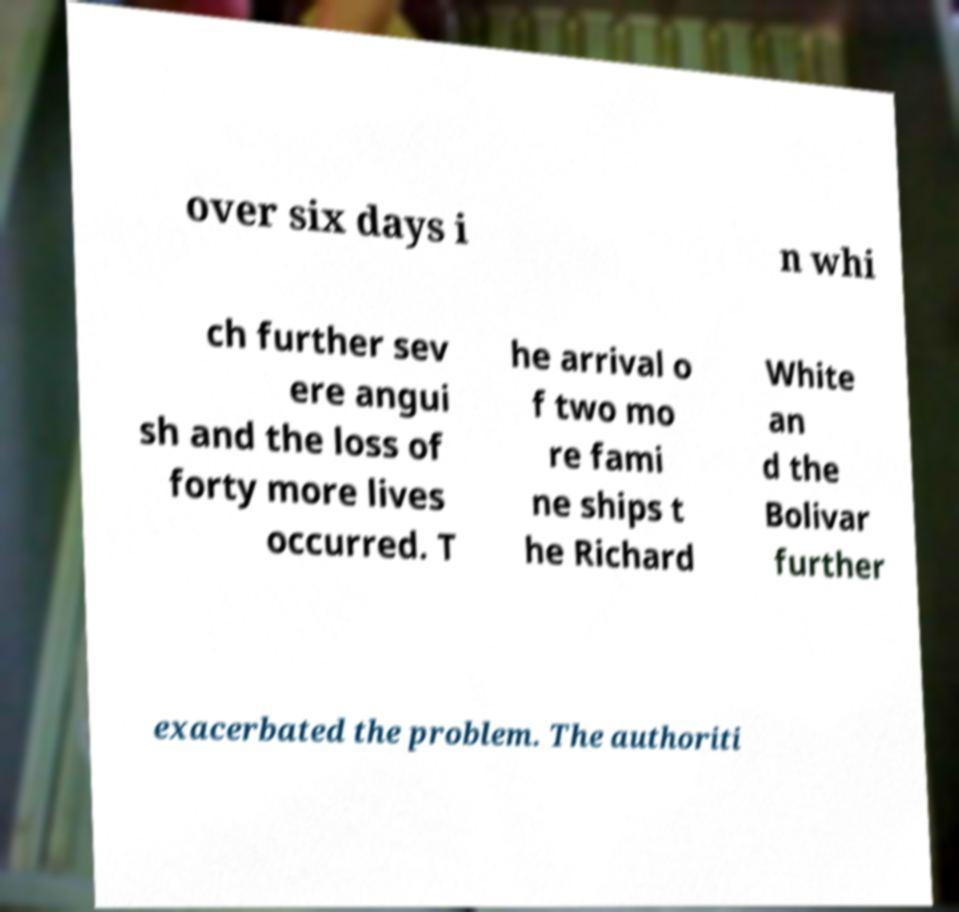What messages or text are displayed in this image? I need them in a readable, typed format. over six days i n whi ch further sev ere angui sh and the loss of forty more lives occurred. T he arrival o f two mo re fami ne ships t he Richard White an d the Bolivar further exacerbated the problem. The authoriti 